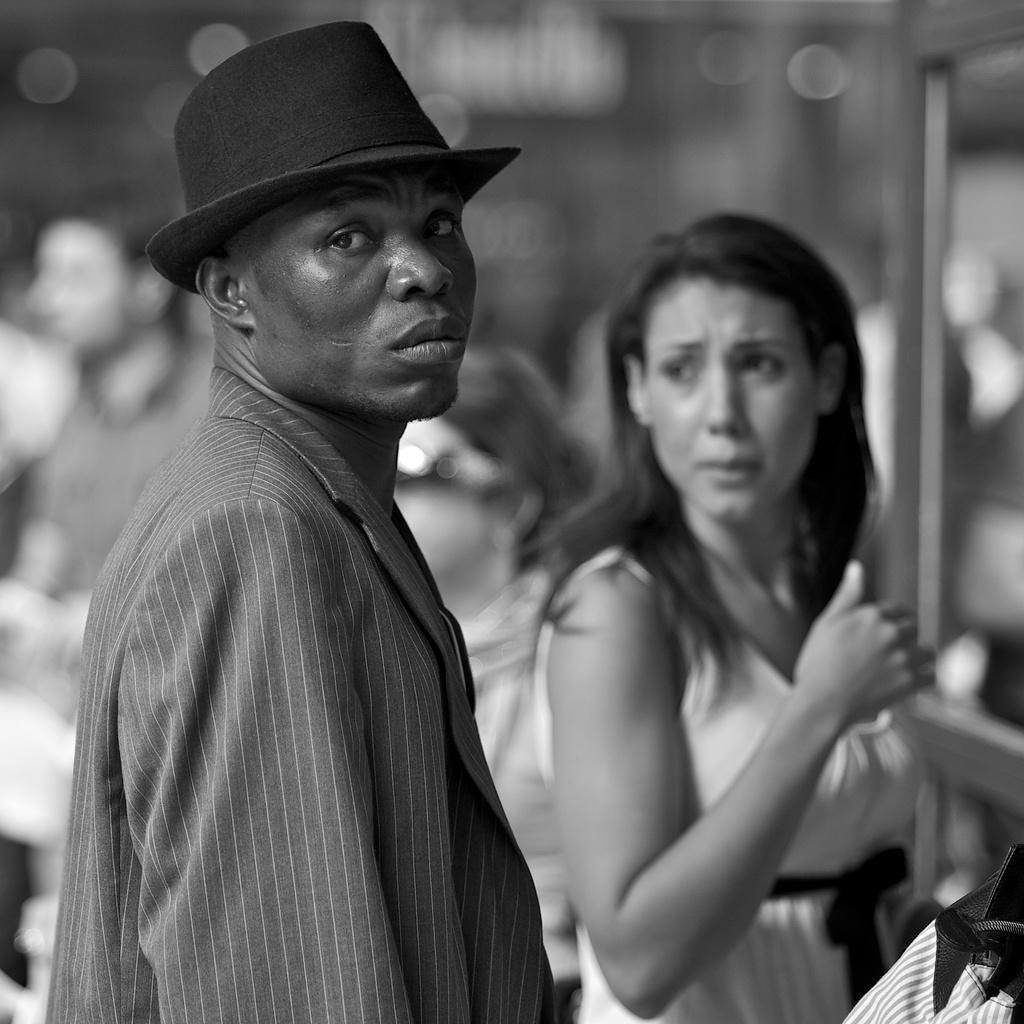What is the color scheme of the image? The image is black and white. Can you describe the subjects in the image? There are a few people in the image. What can be seen on the right side of the image? There are objects on the right side of the image. How would you describe the background of the image? The background of the image is blurred. What type of note is being passed between the people in the image? There is no note being passed between the people in the image, as it is a black and white image with a few people and blurred background. 